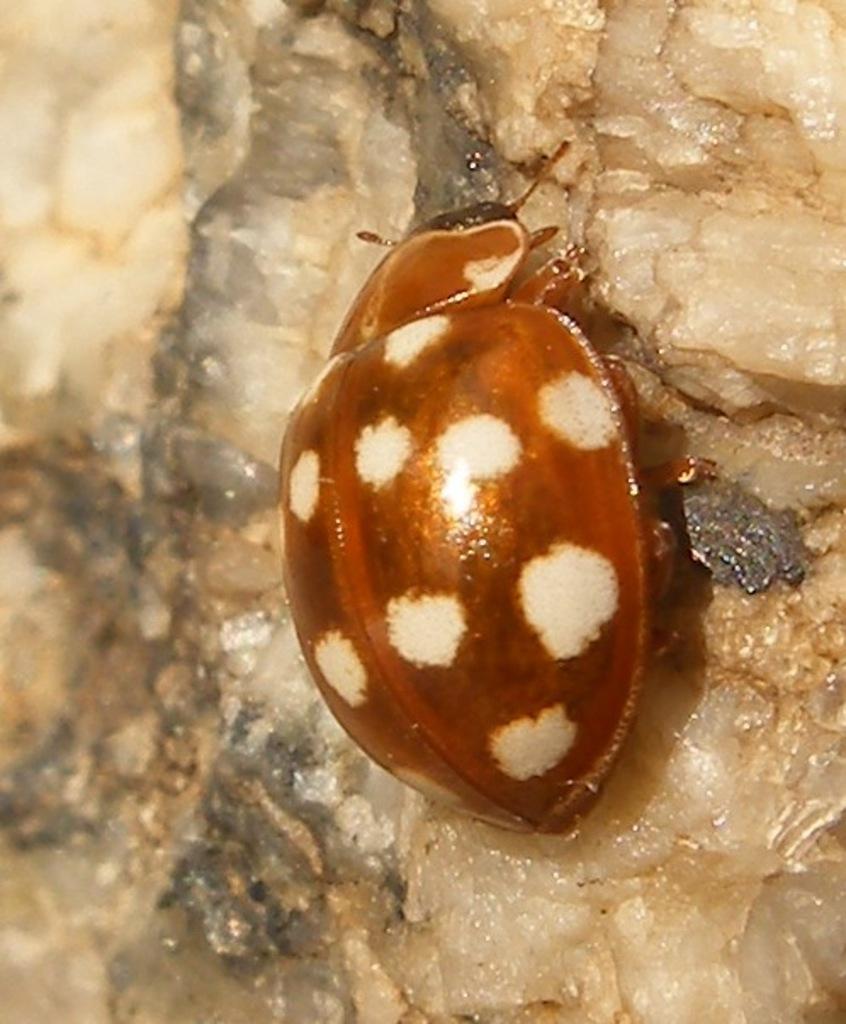Could you give a brief overview of what you see in this image? In the center of the picture there is a beetle, on a stone. 